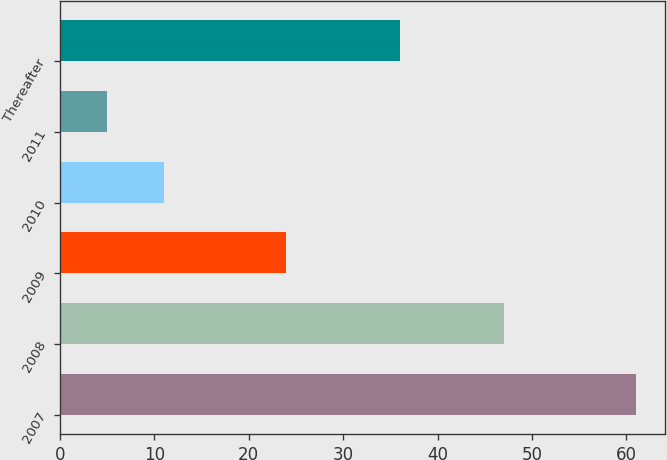Convert chart to OTSL. <chart><loc_0><loc_0><loc_500><loc_500><bar_chart><fcel>2007<fcel>2008<fcel>2009<fcel>2010<fcel>2011<fcel>Thereafter<nl><fcel>61<fcel>47<fcel>24<fcel>11<fcel>5<fcel>36<nl></chart> 